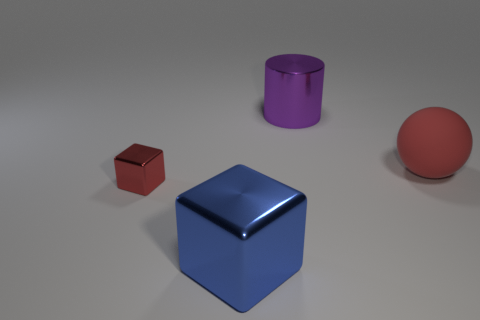Add 3 big red matte spheres. How many objects exist? 7 Subtract all balls. How many objects are left? 3 Subtract 1 cylinders. How many cylinders are left? 0 Subtract all gray metallic objects. Subtract all metallic objects. How many objects are left? 1 Add 1 large purple metallic cylinders. How many large purple metallic cylinders are left? 2 Add 2 red cubes. How many red cubes exist? 3 Subtract all blue blocks. How many blocks are left? 1 Subtract 0 cyan cylinders. How many objects are left? 4 Subtract all yellow balls. Subtract all brown cubes. How many balls are left? 1 Subtract all cyan spheres. How many blue cubes are left? 1 